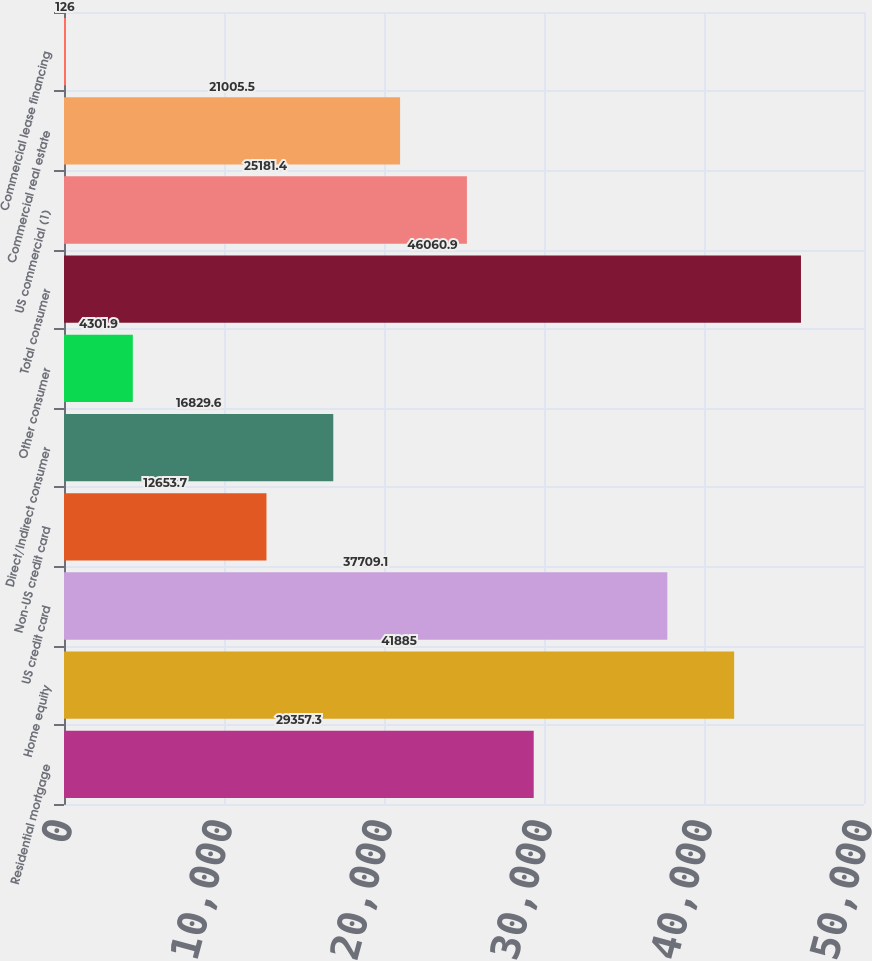<chart> <loc_0><loc_0><loc_500><loc_500><bar_chart><fcel>Residential mortgage<fcel>Home equity<fcel>US credit card<fcel>Non-US credit card<fcel>Direct/Indirect consumer<fcel>Other consumer<fcel>Total consumer<fcel>US commercial (1)<fcel>Commercial real estate<fcel>Commercial lease financing<nl><fcel>29357.3<fcel>41885<fcel>37709.1<fcel>12653.7<fcel>16829.6<fcel>4301.9<fcel>46060.9<fcel>25181.4<fcel>21005.5<fcel>126<nl></chart> 